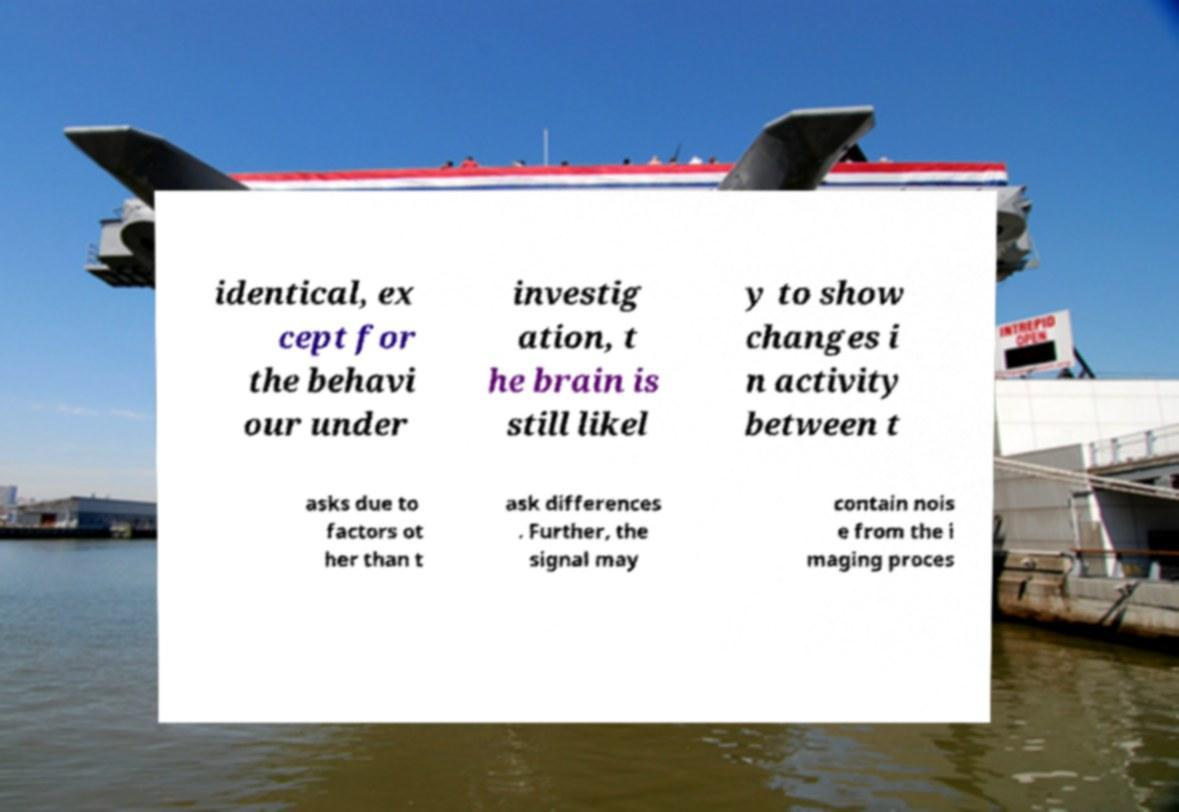Could you extract and type out the text from this image? identical, ex cept for the behavi our under investig ation, t he brain is still likel y to show changes i n activity between t asks due to factors ot her than t ask differences . Further, the signal may contain nois e from the i maging proces 